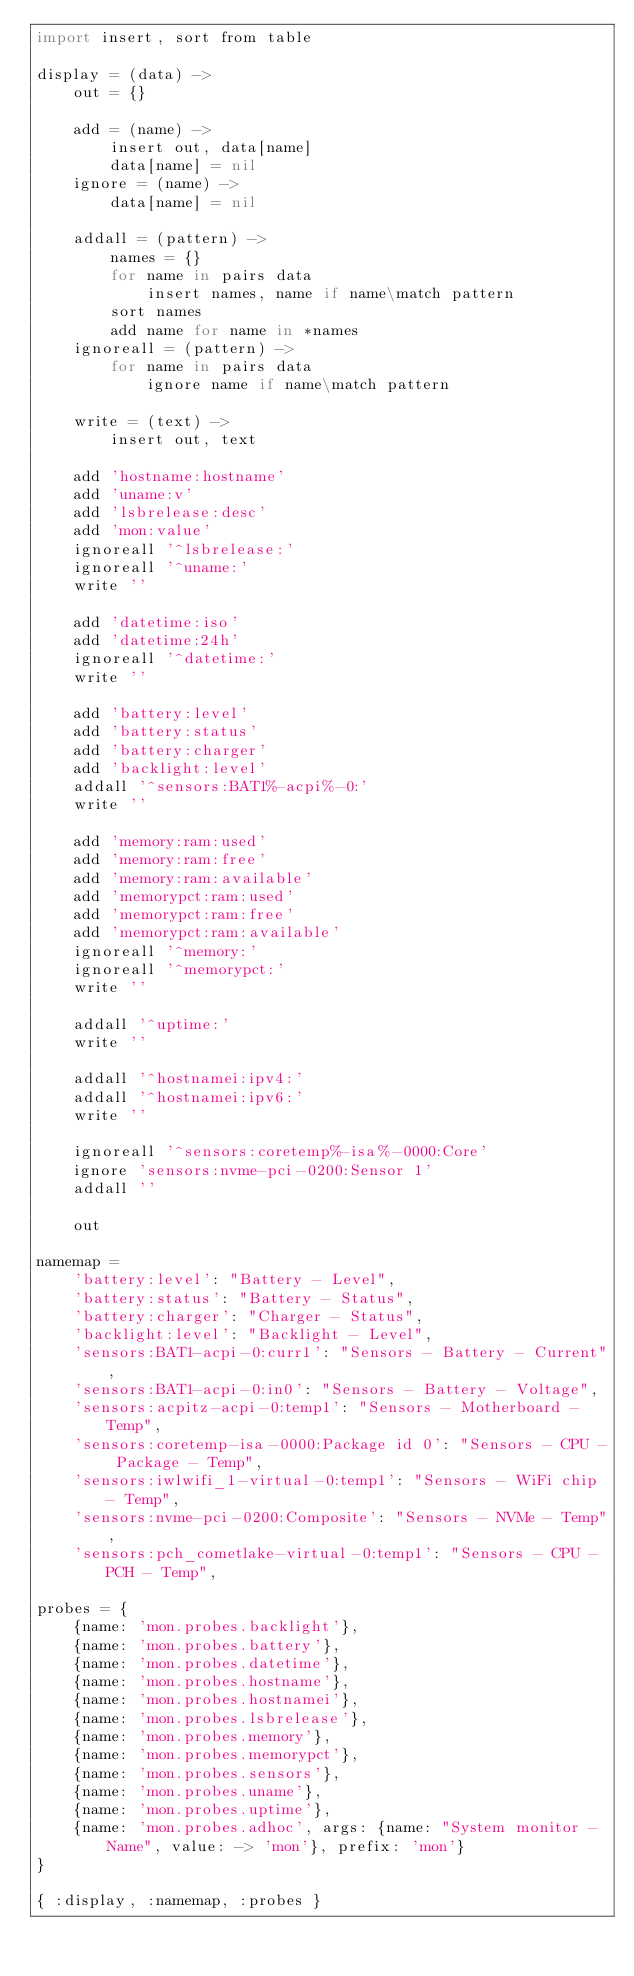Convert code to text. <code><loc_0><loc_0><loc_500><loc_500><_MoonScript_>import insert, sort from table

display = (data) ->
	out = {}

	add = (name) ->
		insert out, data[name]
		data[name] = nil
	ignore = (name) ->
		data[name] = nil
	
	addall = (pattern) ->
		names = {}
		for name in pairs data
			insert names, name if name\match pattern
		sort names
		add name for name in *names
	ignoreall = (pattern) ->
		for name in pairs data
			ignore name if name\match pattern

	write = (text) ->
		insert out, text

	add 'hostname:hostname'
	add 'uname:v'
	add 'lsbrelease:desc'
	add 'mon:value'
	ignoreall '^lsbrelease:'
	ignoreall '^uname:'
	write ''

	add 'datetime:iso'
	add 'datetime:24h'
	ignoreall '^datetime:'
	write ''

	add 'battery:level'
	add 'battery:status'
	add 'battery:charger'
	add 'backlight:level'
	addall '^sensors:BAT1%-acpi%-0:'
	write ''

	add 'memory:ram:used'
	add 'memory:ram:free'
	add 'memory:ram:available'
	add 'memorypct:ram:used'
	add 'memorypct:ram:free'
	add 'memorypct:ram:available'
	ignoreall '^memory:'
	ignoreall '^memorypct:'
	write ''

	addall '^uptime:'
	write ''

	addall '^hostnamei:ipv4:'
	addall '^hostnamei:ipv6:'
	write ''

	ignoreall '^sensors:coretemp%-isa%-0000:Core'
	ignore 'sensors:nvme-pci-0200:Sensor 1'
	addall ''

	out

namemap =
	'battery:level': "Battery - Level",
	'battery:status': "Battery - Status",
	'battery:charger': "Charger - Status",
	'backlight:level': "Backlight - Level",
	'sensors:BAT1-acpi-0:curr1': "Sensors - Battery - Current",
	'sensors:BAT1-acpi-0:in0': "Sensors - Battery - Voltage",
	'sensors:acpitz-acpi-0:temp1': "Sensors - Motherboard - Temp",
	'sensors:coretemp-isa-0000:Package id 0': "Sensors - CPU - Package - Temp",
	'sensors:iwlwifi_1-virtual-0:temp1': "Sensors - WiFi chip - Temp",
	'sensors:nvme-pci-0200:Composite': "Sensors - NVMe - Temp",
	'sensors:pch_cometlake-virtual-0:temp1': "Sensors - CPU - PCH - Temp",

probes = {
	{name: 'mon.probes.backlight'},
	{name: 'mon.probes.battery'},
	{name: 'mon.probes.datetime'},
	{name: 'mon.probes.hostname'},
	{name: 'mon.probes.hostnamei'},
	{name: 'mon.probes.lsbrelease'},
	{name: 'mon.probes.memory'},
	{name: 'mon.probes.memorypct'},
	{name: 'mon.probes.sensors'},
	{name: 'mon.probes.uname'},
	{name: 'mon.probes.uptime'},
	{name: 'mon.probes.adhoc', args: {name: "System monitor - Name", value: -> 'mon'}, prefix: 'mon'}
}

{ :display, :namemap, :probes }
</code> 